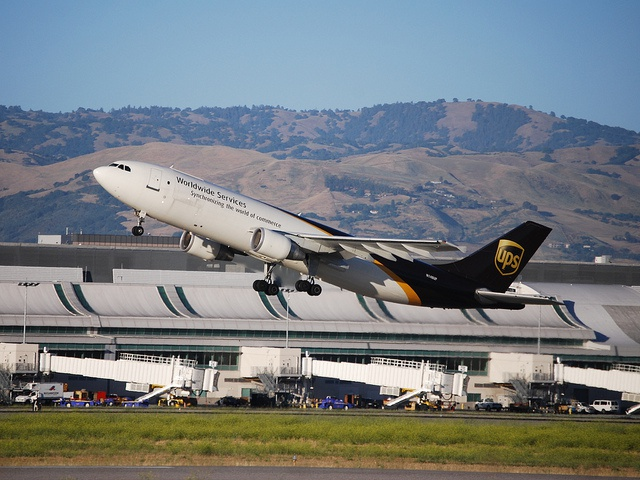Describe the objects in this image and their specific colors. I can see airplane in gray, black, lightgray, and darkgray tones, truck in gray, darkgray, black, and navy tones, car in gray, black, lightgray, and darkgray tones, car in gray, navy, black, blue, and darkblue tones, and truck in gray, black, lightgray, and darkgray tones in this image. 